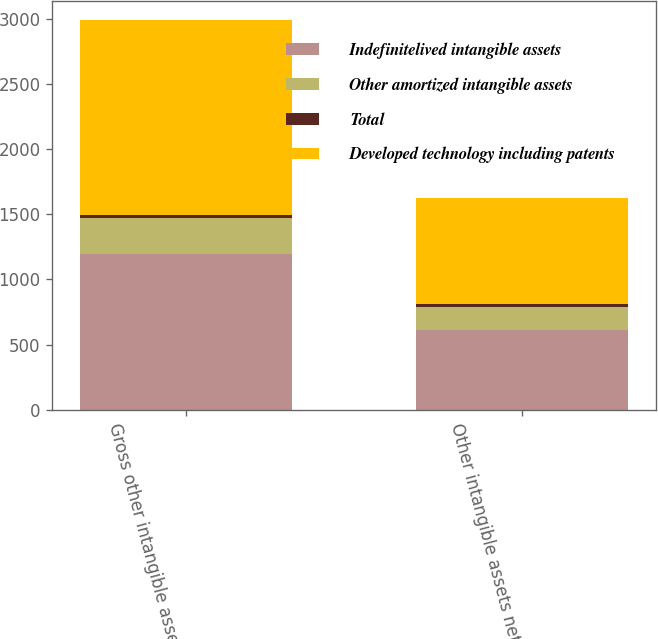Convert chart to OTSL. <chart><loc_0><loc_0><loc_500><loc_500><stacked_bar_chart><ecel><fcel>Gross other intangible assets<fcel>Other intangible assets net<nl><fcel>Indefinitelived intangible assets<fcel>1192<fcel>614<nl><fcel>Other amortized intangible assets<fcel>280<fcel>178<nl><fcel>Total<fcel>22<fcel>22<nl><fcel>Developed technology including patents<fcel>1494<fcel>814<nl></chart> 